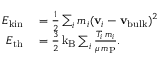Convert formula to latex. <formula><loc_0><loc_0><loc_500><loc_500>\begin{array} { r l } { E _ { k i n } } & = \frac { 1 } { 2 } \sum _ { i } m _ { i } ( { v } _ { i } - { v _ { b u l k } } ) ^ { 2 } } \\ { E _ { t h } } & = \frac { 3 } { 2 } \, k _ { B } \sum _ { i } \frac { T _ { i } \, m _ { i } } { \mu \, m _ { P } } . } \end{array}</formula> 